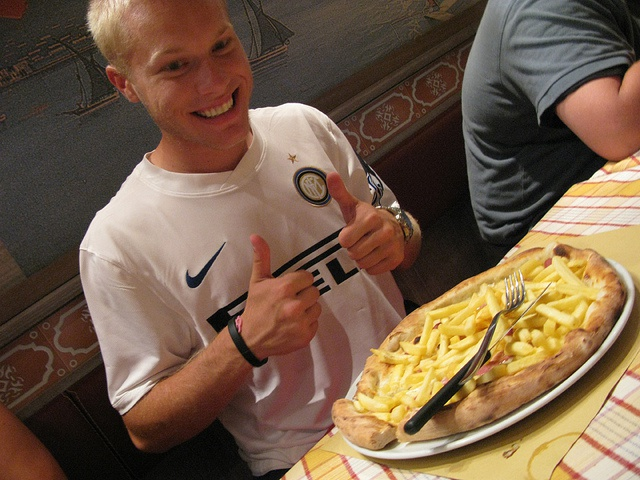Describe the objects in this image and their specific colors. I can see people in black, gray, maroon, darkgray, and brown tones, people in black, gray, and brown tones, pizza in black, tan, khaki, and orange tones, bench in black, gray, and darkgray tones, and dining table in black, tan, beige, and khaki tones in this image. 